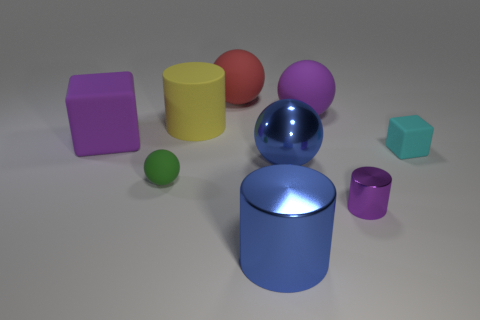Does the small cylinder have the same material as the big blue ball?
Provide a succinct answer. Yes. What is the material of the purple cylinder?
Give a very brief answer. Metal. Is the number of purple metal cylinders that are right of the purple shiny cylinder the same as the number of big yellow metal spheres?
Keep it short and to the point. Yes. There is a large block; are there any small things behind it?
Provide a succinct answer. No. How many rubber things are either green balls or balls?
Offer a terse response. 3. There is a purple sphere; how many tiny metal objects are to the right of it?
Your answer should be compact. 1. Are there any yellow cylinders of the same size as the cyan rubber block?
Give a very brief answer. No. Are there any other things that have the same color as the tiny metal thing?
Your response must be concise. Yes. How many large metallic spheres are the same color as the big cube?
Keep it short and to the point. 0. Do the tiny metal thing and the big thing that is on the left side of the yellow cylinder have the same color?
Your response must be concise. Yes. 